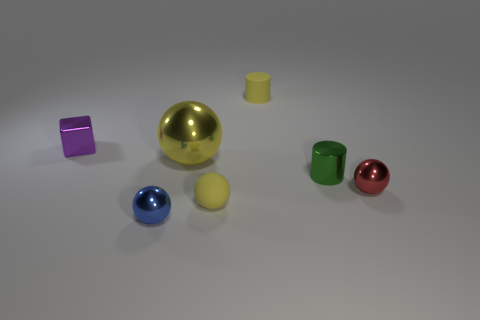Add 2 small metallic things. How many objects exist? 9 Subtract all tiny red metal objects. Subtract all small yellow cylinders. How many objects are left? 5 Add 6 small shiny balls. How many small shiny balls are left? 8 Add 6 big spheres. How many big spheres exist? 7 Subtract all green cylinders. How many cylinders are left? 1 Subtract all tiny spheres. How many spheres are left? 1 Subtract 0 yellow cubes. How many objects are left? 7 Subtract all cylinders. How many objects are left? 5 Subtract 1 cylinders. How many cylinders are left? 1 Subtract all red balls. Subtract all red cubes. How many balls are left? 3 